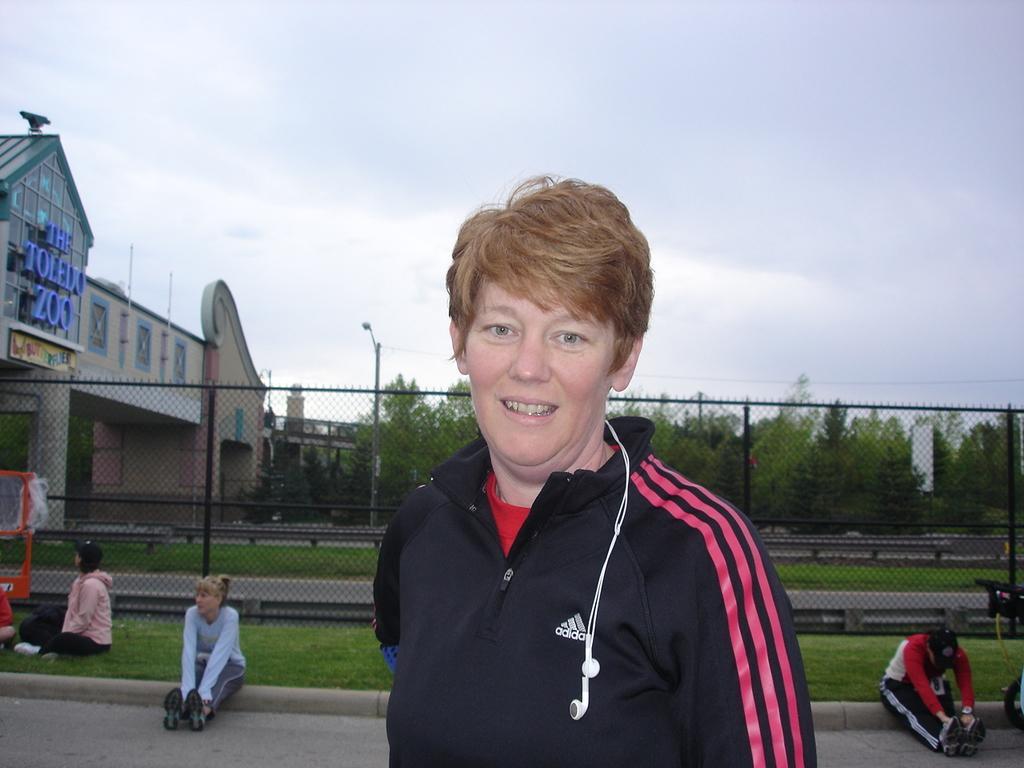Could you give a brief overview of what you see in this image? In the image we can see there is a person standing and he is wearing jacket. Its written ¨adidas¨ on the jacket and there are earphones on the jacket. There are other people sitting on the ground and there's grass on the ground. There is an iron fencing and behind there is a building. There are lot of trees. 